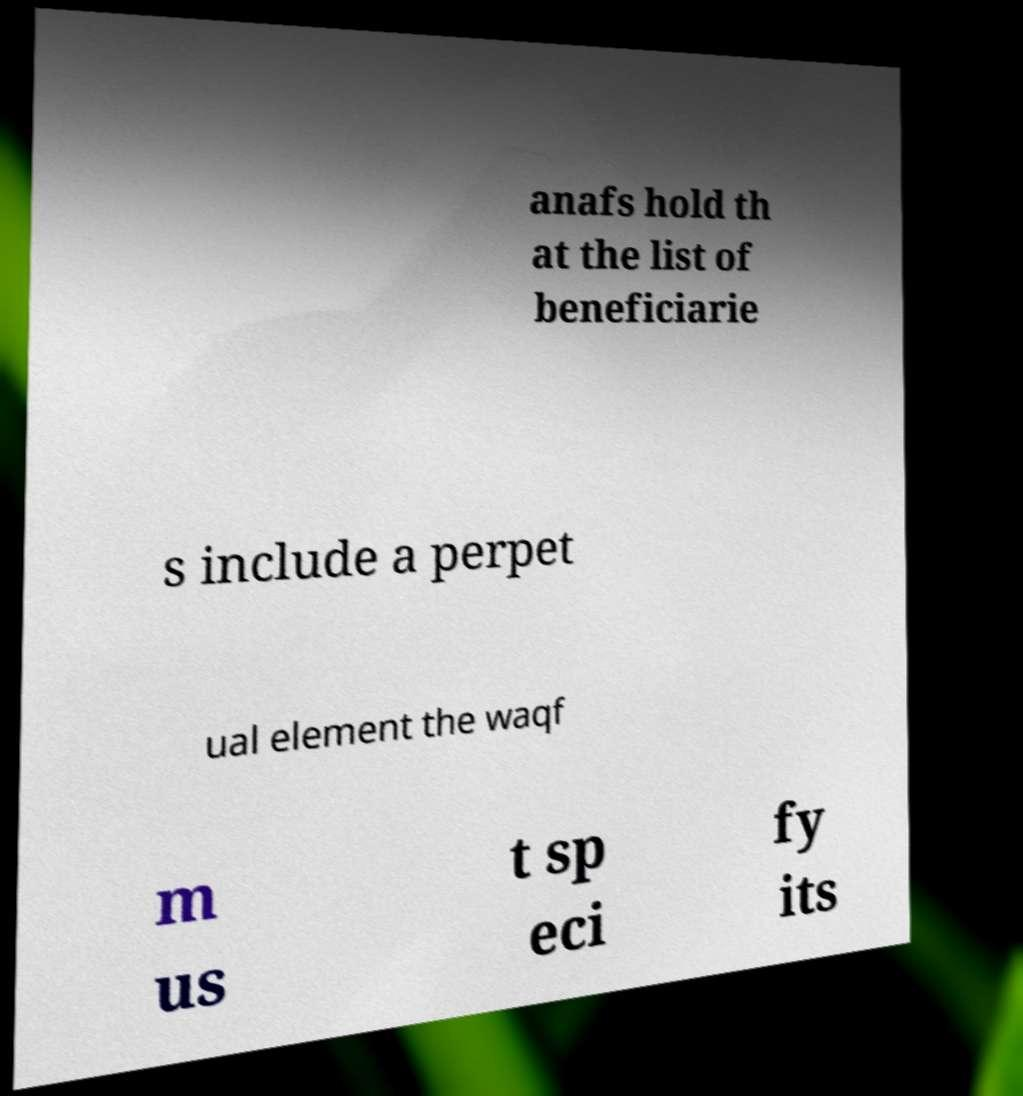Could you assist in decoding the text presented in this image and type it out clearly? anafs hold th at the list of beneficiarie s include a perpet ual element the waqf m us t sp eci fy its 